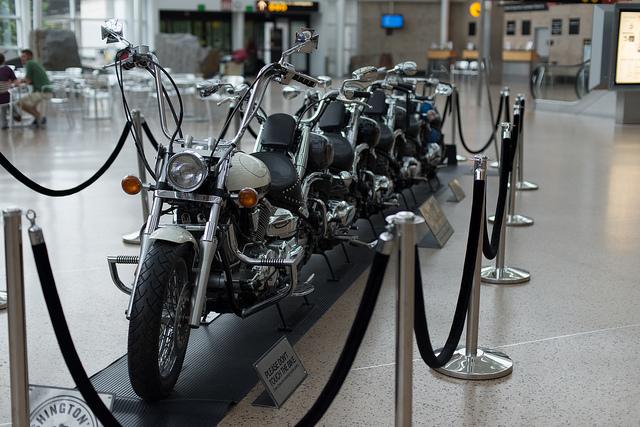Is it on display?
Concise answer only. Yes. Is this cycle unusual?
Give a very brief answer. Yes. How many passengers can this motorcycle accommodate?
Give a very brief answer. 1. 